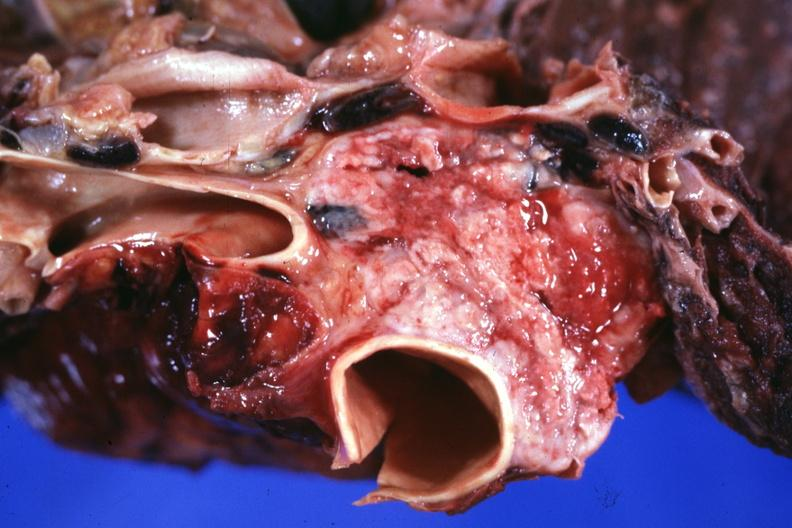s heart present?
Answer the question using a single word or phrase. No 